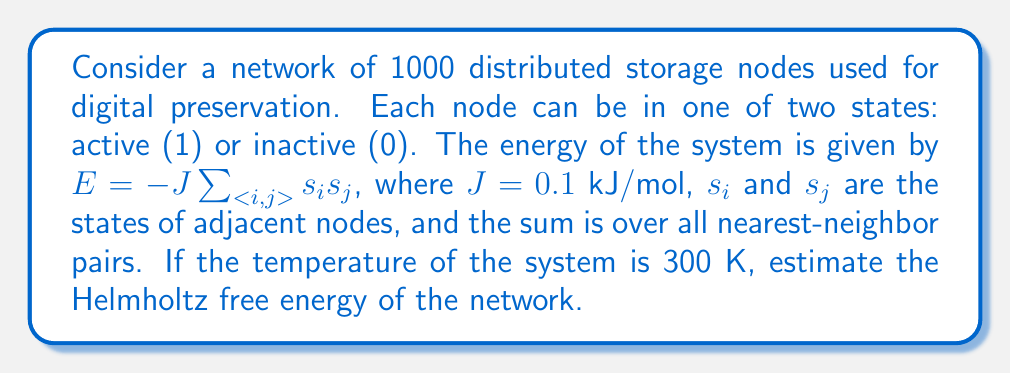Could you help me with this problem? To estimate the Helmholtz free energy of the network, we'll use the mean-field approximation for the Ising model, which is applicable to this system of distributed storage nodes.

Step 1: Define the partition function Z
The partition function in the mean-field approximation is given by:
$$Z = [2\cosh(\beta J z m)]^N$$
where $\beta = \frac{1}{k_B T}$, $N$ is the number of nodes, $z$ is the number of nearest neighbors, and $m$ is the average magnetization.

Step 2: Calculate $\beta$
$\beta = \frac{1}{k_B T} = \frac{1}{(1.38064852 \times 10^{-23} \text{ J/K})(300 \text{ K})} = 2.4151 \times 10^{20} \text{ J}^{-1}$

Step 3: Estimate $z$ and $m$
For a typical network, we can assume $z \approx 6$ (each node connected to 6 others on average).
At high temperature, we can approximate $m \approx 0$ (random distribution of active/inactive nodes).

Step 4: Calculate $\beta J z m$
$\beta J z m = (2.4151 \times 10^{20} \text{ J}^{-1})(0.1 \times 10^{-3} \text{ J/mol})(6)(0) = 0$

Step 5: Compute the partition function Z
$$Z = [2\cosh(0)]^{1000} = 2^{1000}$$

Step 6: Calculate the Helmholtz free energy
The Helmholtz free energy is given by $F = -k_B T \ln Z$
$$F = -(1.38064852 \times 10^{-23} \text{ J/K})(300 \text{ K})(\ln 2^{1000})$$
$$F = -4.14194556 \times 10^{-21} \text{ J} \times 1000 \ln 2$$
$$F = -2.87126 \times 10^{-18} \text{ J}$$

Step 7: Convert to kJ/mol
$F = -2.87126 \times 10^{-18} \text{ J} \times \frac{6.022 \times 10^{23}}{1000} = -1.729 \text{ kJ/mol}$
Answer: $-1.729 \text{ kJ/mol}$ 